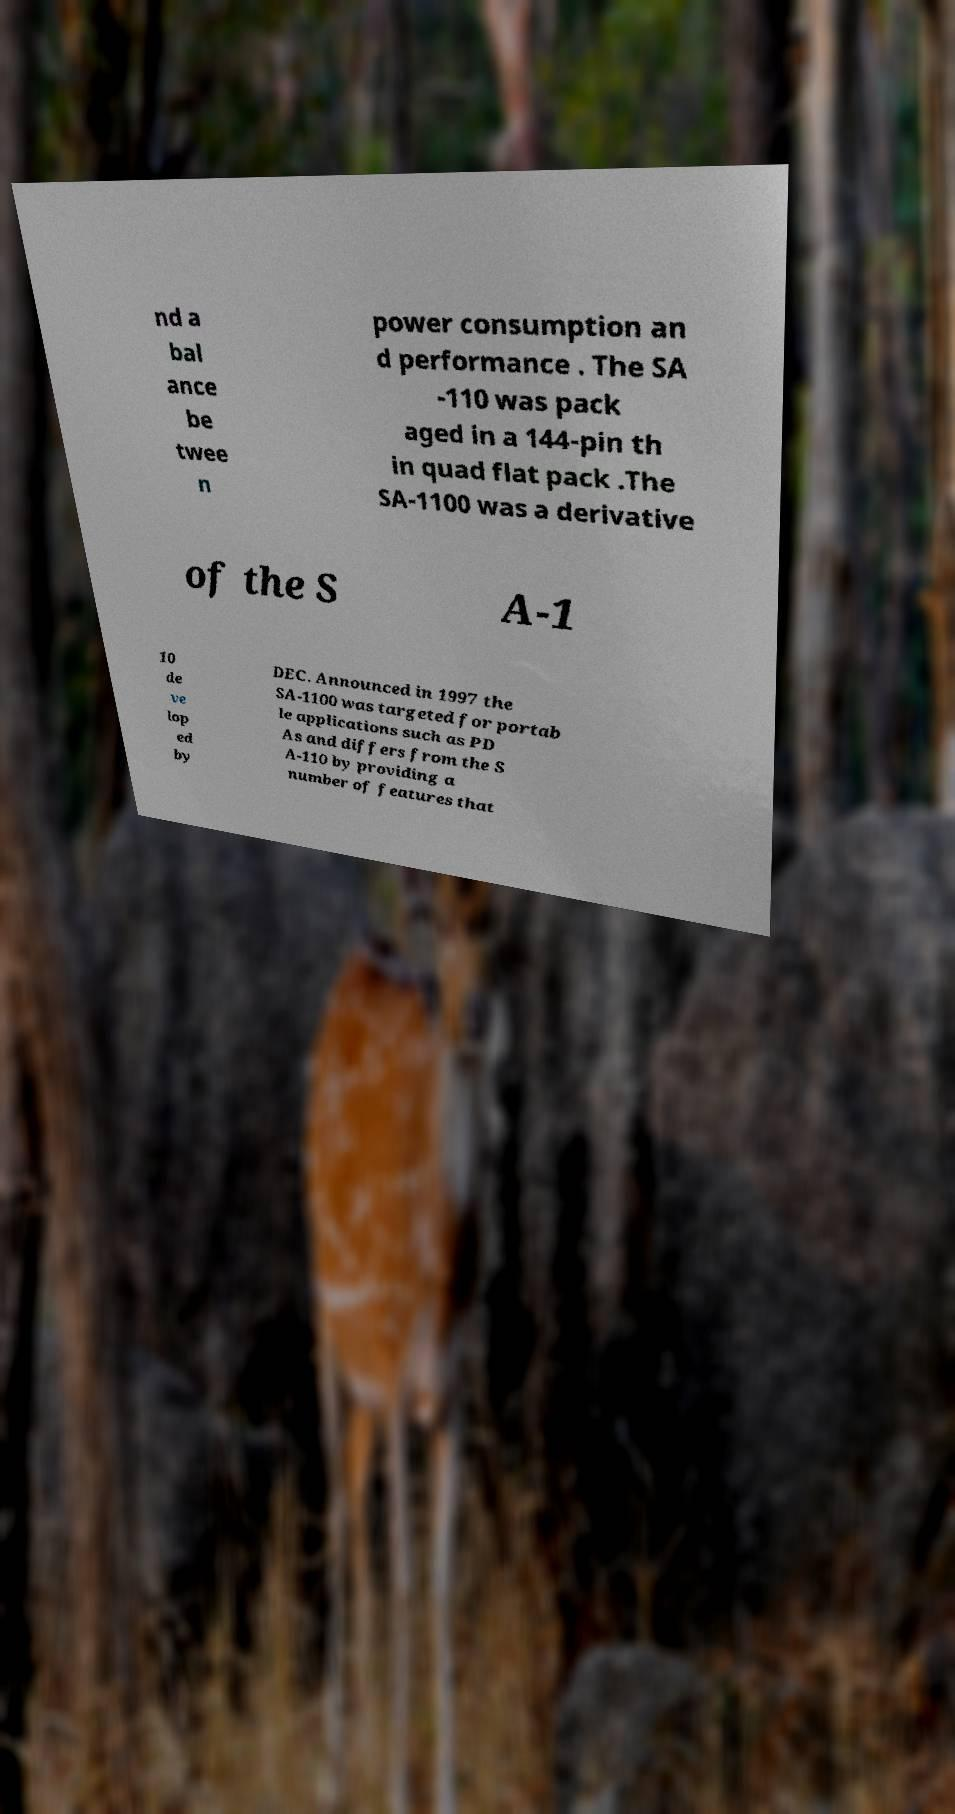Can you read and provide the text displayed in the image?This photo seems to have some interesting text. Can you extract and type it out for me? nd a bal ance be twee n power consumption an d performance . The SA -110 was pack aged in a 144-pin th in quad flat pack .The SA-1100 was a derivative of the S A-1 10 de ve lop ed by DEC. Announced in 1997 the SA-1100 was targeted for portab le applications such as PD As and differs from the S A-110 by providing a number of features that 